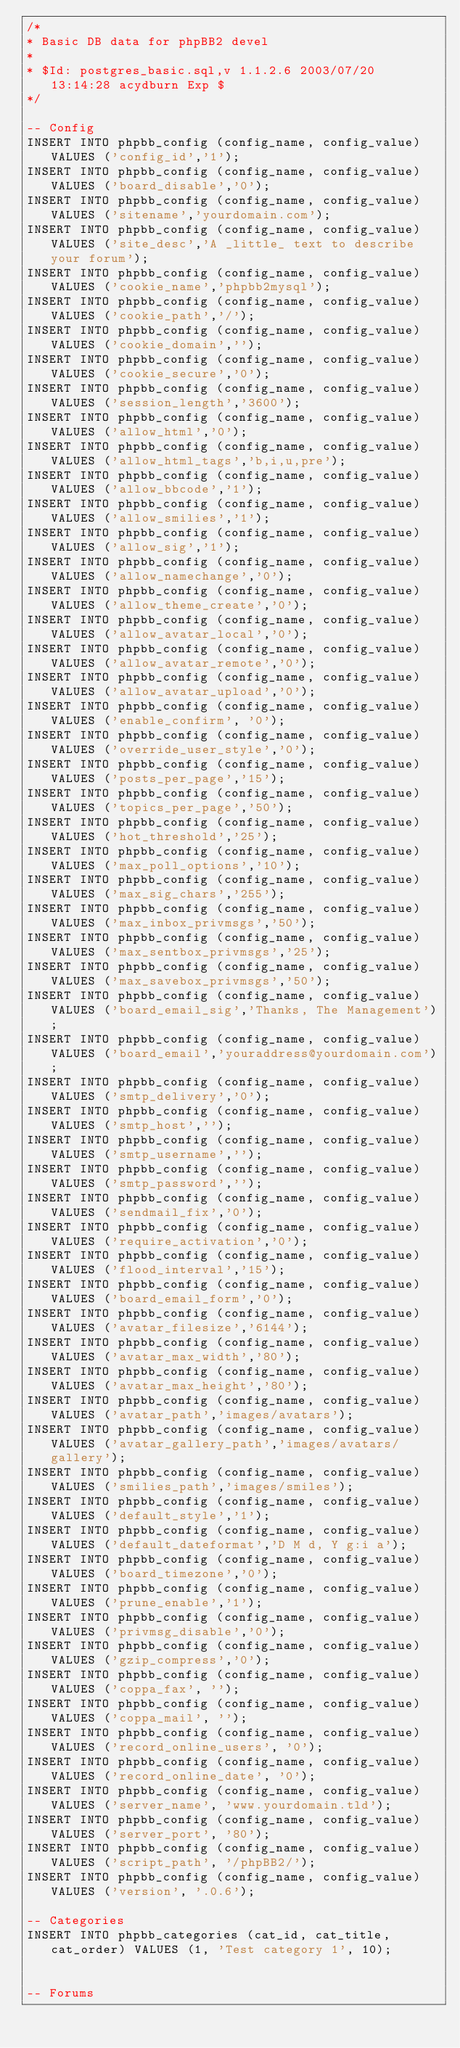Convert code to text. <code><loc_0><loc_0><loc_500><loc_500><_SQL_>/*
* Basic DB data for phpBB2 devel
*
* $Id: postgres_basic.sql,v 1.1.2.6 2003/07/20 13:14:28 acydburn Exp $
*/

-- Config
INSERT INTO phpbb_config (config_name, config_value) VALUES ('config_id','1');
INSERT INTO phpbb_config (config_name, config_value) VALUES ('board_disable','0');
INSERT INTO phpbb_config (config_name, config_value) VALUES ('sitename','yourdomain.com');
INSERT INTO phpbb_config (config_name, config_value) VALUES ('site_desc','A _little_ text to describe your forum');
INSERT INTO phpbb_config (config_name, config_value) VALUES ('cookie_name','phpbb2mysql');
INSERT INTO phpbb_config (config_name, config_value) VALUES ('cookie_path','/');
INSERT INTO phpbb_config (config_name, config_value) VALUES ('cookie_domain','');
INSERT INTO phpbb_config (config_name, config_value) VALUES ('cookie_secure','0');
INSERT INTO phpbb_config (config_name, config_value) VALUES ('session_length','3600');
INSERT INTO phpbb_config (config_name, config_value) VALUES ('allow_html','0');
INSERT INTO phpbb_config (config_name, config_value) VALUES ('allow_html_tags','b,i,u,pre');
INSERT INTO phpbb_config (config_name, config_value) VALUES ('allow_bbcode','1');
INSERT INTO phpbb_config (config_name, config_value) VALUES ('allow_smilies','1');
INSERT INTO phpbb_config (config_name, config_value) VALUES ('allow_sig','1');
INSERT INTO phpbb_config (config_name, config_value) VALUES ('allow_namechange','0');
INSERT INTO phpbb_config (config_name, config_value) VALUES ('allow_theme_create','0');
INSERT INTO phpbb_config (config_name, config_value) VALUES ('allow_avatar_local','0');
INSERT INTO phpbb_config (config_name, config_value) VALUES ('allow_avatar_remote','0');
INSERT INTO phpbb_config (config_name, config_value) VALUES ('allow_avatar_upload','0');
INSERT INTO phpbb_config (config_name, config_value) VALUES ('enable_confirm', '0');
INSERT INTO phpbb_config (config_name, config_value) VALUES ('override_user_style','0');
INSERT INTO phpbb_config (config_name, config_value) VALUES ('posts_per_page','15');
INSERT INTO phpbb_config (config_name, config_value) VALUES ('topics_per_page','50');
INSERT INTO phpbb_config (config_name, config_value) VALUES ('hot_threshold','25');
INSERT INTO phpbb_config (config_name, config_value) VALUES ('max_poll_options','10');
INSERT INTO phpbb_config (config_name, config_value) VALUES ('max_sig_chars','255');
INSERT INTO phpbb_config (config_name, config_value) VALUES ('max_inbox_privmsgs','50');
INSERT INTO phpbb_config (config_name, config_value) VALUES ('max_sentbox_privmsgs','25');
INSERT INTO phpbb_config (config_name, config_value) VALUES ('max_savebox_privmsgs','50');
INSERT INTO phpbb_config (config_name, config_value) VALUES ('board_email_sig','Thanks, The Management');
INSERT INTO phpbb_config (config_name, config_value) VALUES ('board_email','youraddress@yourdomain.com');
INSERT INTO phpbb_config (config_name, config_value) VALUES ('smtp_delivery','0');
INSERT INTO phpbb_config (config_name, config_value) VALUES ('smtp_host','');
INSERT INTO phpbb_config (config_name, config_value) VALUES ('smtp_username','');
INSERT INTO phpbb_config (config_name, config_value) VALUES ('smtp_password','');
INSERT INTO phpbb_config (config_name, config_value) VALUES ('sendmail_fix','0');
INSERT INTO phpbb_config (config_name, config_value) VALUES ('require_activation','0');
INSERT INTO phpbb_config (config_name, config_value) VALUES ('flood_interval','15');
INSERT INTO phpbb_config (config_name, config_value) VALUES ('board_email_form','0');
INSERT INTO phpbb_config (config_name, config_value) VALUES ('avatar_filesize','6144');
INSERT INTO phpbb_config (config_name, config_value) VALUES ('avatar_max_width','80');
INSERT INTO phpbb_config (config_name, config_value) VALUES ('avatar_max_height','80');
INSERT INTO phpbb_config (config_name, config_value) VALUES ('avatar_path','images/avatars');
INSERT INTO phpbb_config (config_name, config_value) VALUES ('avatar_gallery_path','images/avatars/gallery');
INSERT INTO phpbb_config (config_name, config_value) VALUES ('smilies_path','images/smiles');
INSERT INTO phpbb_config (config_name, config_value) VALUES ('default_style','1');
INSERT INTO phpbb_config (config_name, config_value) VALUES ('default_dateformat','D M d, Y g:i a');
INSERT INTO phpbb_config (config_name, config_value) VALUES ('board_timezone','0');
INSERT INTO phpbb_config (config_name, config_value) VALUES ('prune_enable','1');
INSERT INTO phpbb_config (config_name, config_value) VALUES ('privmsg_disable','0');
INSERT INTO phpbb_config (config_name, config_value) VALUES ('gzip_compress','0');
INSERT INTO phpbb_config (config_name, config_value) VALUES ('coppa_fax', '');
INSERT INTO phpbb_config (config_name, config_value) VALUES ('coppa_mail', '');
INSERT INTO phpbb_config (config_name, config_value) VALUES ('record_online_users', '0');
INSERT INTO phpbb_config (config_name, config_value) VALUES ('record_online_date', '0');
INSERT INTO phpbb_config (config_name, config_value) VALUES ('server_name', 'www.yourdomain.tld');
INSERT INTO phpbb_config (config_name, config_value) VALUES ('server_port', '80');
INSERT INTO phpbb_config (config_name, config_value) VALUES ('script_path', '/phpBB2/');
INSERT INTO phpbb_config (config_name, config_value) VALUES ('version', '.0.6');

-- Categories
INSERT INTO phpbb_categories (cat_id, cat_title, cat_order) VALUES (1, 'Test category 1', 10);


-- Forums</code> 